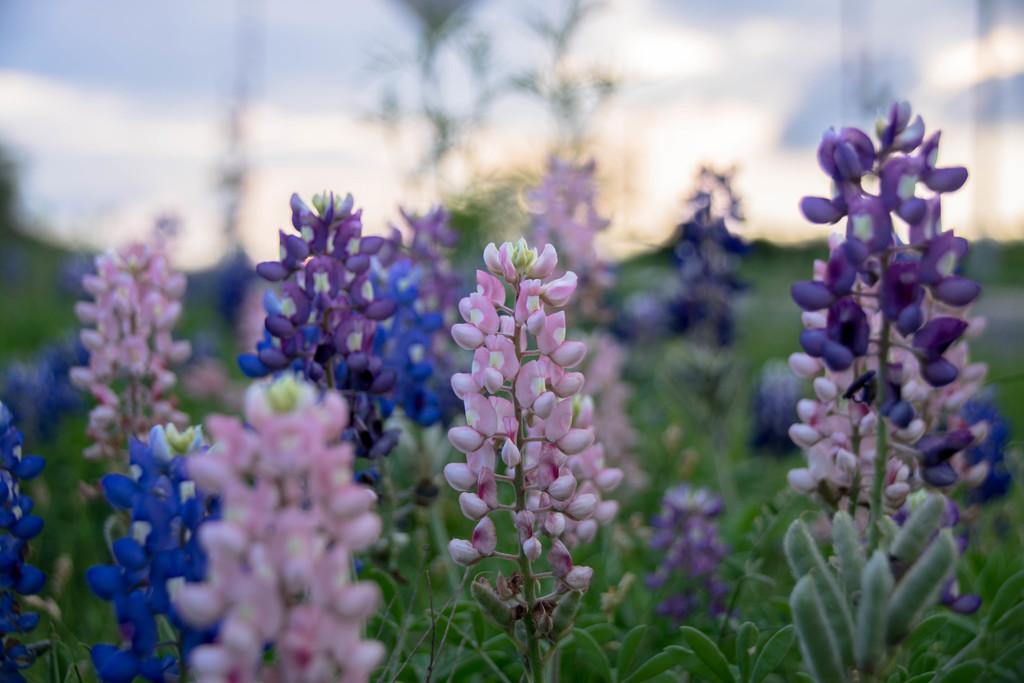Describe this image in one or two sentences. In this image we can see flowers to the plants. 